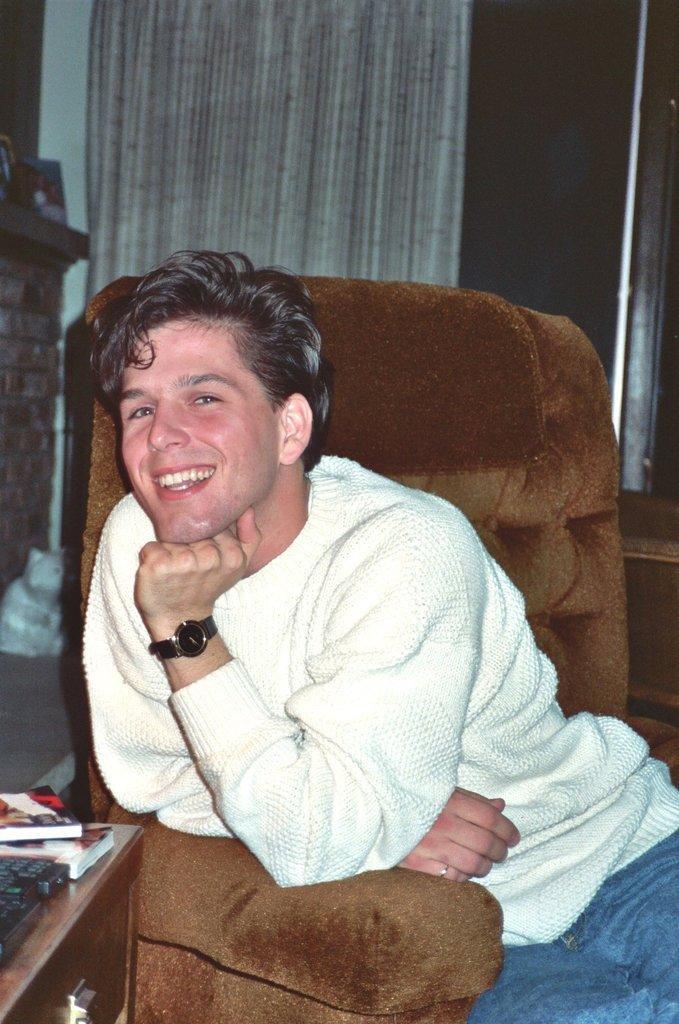Can you describe this image briefly? In this image I can see a person sitting on the chair. At the back side there is a curtain. On the table there are books. 